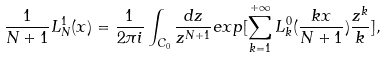<formula> <loc_0><loc_0><loc_500><loc_500>\frac { 1 } { N + 1 } L _ { N } ^ { 1 } ( x ) = \frac { 1 } { 2 \pi i } \int _ { C _ { 0 } } \frac { d z } { z ^ { N + 1 } } e x p [ \sum _ { k = 1 } ^ { + \infty } L _ { k } ^ { 0 } ( \frac { k x } { N + 1 } ) \frac { z ^ { k } } { k } ] ,</formula> 